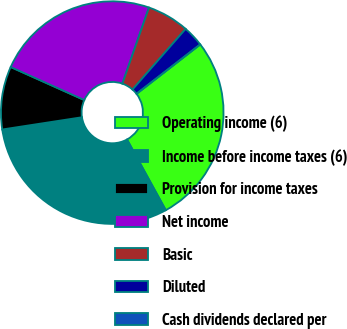<chart> <loc_0><loc_0><loc_500><loc_500><pie_chart><fcel>Operating income (6)<fcel>Income before income taxes (6)<fcel>Provision for income taxes<fcel>Net income<fcel>Basic<fcel>Diluted<fcel>Cash dividends declared per<nl><fcel>27.51%<fcel>30.56%<fcel>9.14%<fcel>23.64%<fcel>6.1%<fcel>3.05%<fcel>0.0%<nl></chart> 